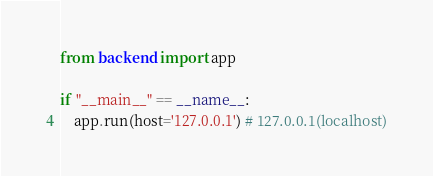Convert code to text. <code><loc_0><loc_0><loc_500><loc_500><_Python_>
from backend import app

if "__main__" == __name__:
    app.run(host='127.0.0.1') # 127.0.0.1(localhost)</code> 